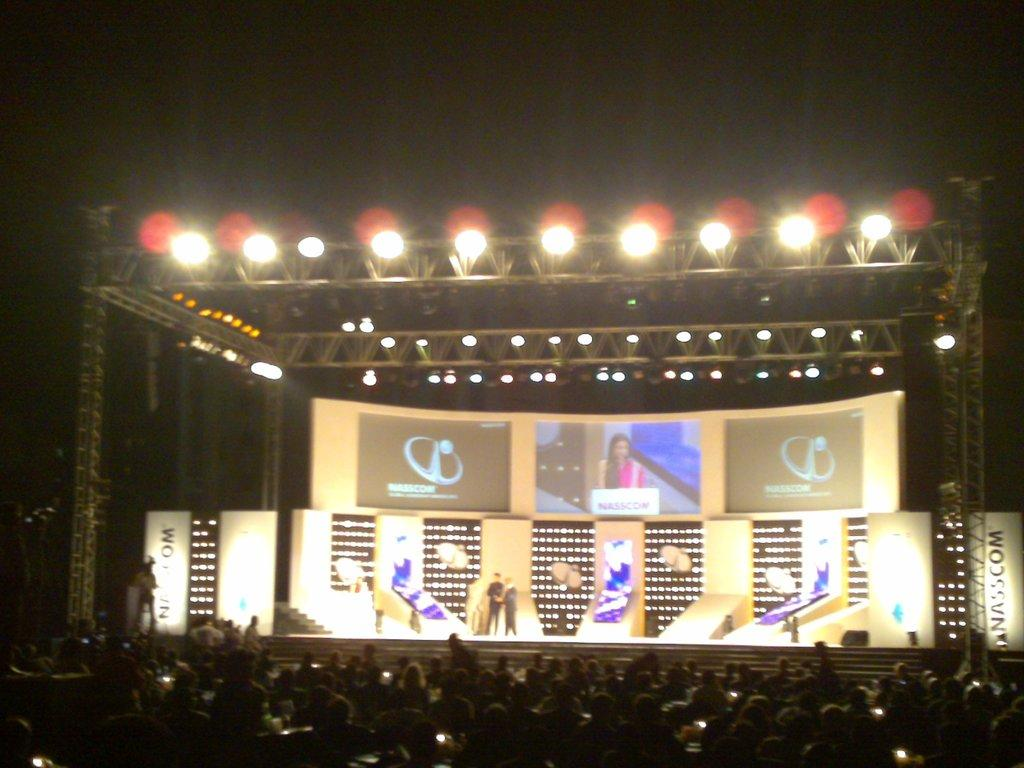What can be seen in the image in terms of people? There are groups of people in the image. What else is present in the image besides people? Banners and lights are visible in the image. How would you describe the overall lighting in the image? The image is slightly dark. What date is marked on the calendar in the image? There is no calendar present in the image. How does the war affect the people in the image? There is no mention of war in the image, so it cannot be determined how it would affect the people. 